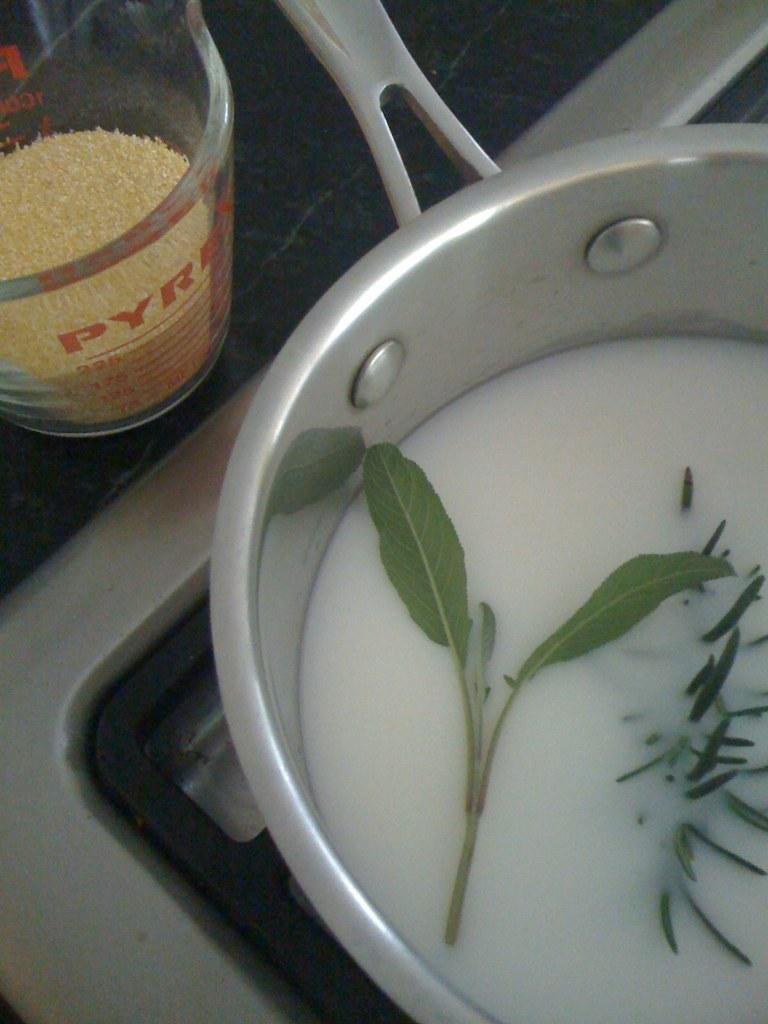How would you summarize this image in a sentence or two? In this image there is bowl with some liquid and leaves in it. To the left side of the image there is a glass with some item in it. 